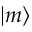<formula> <loc_0><loc_0><loc_500><loc_500>| m \rangle</formula> 